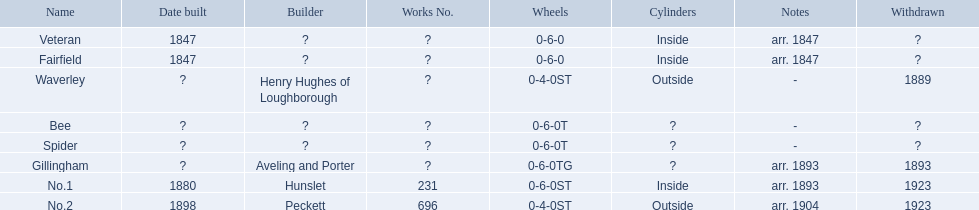What are the names of the alderney railway? Veteran, Fairfield, Waverley, Bee, Spider, Gillingham, No.1, No.2. When was the farfield constructed? 1847. What other structures were erected that year? Veteran. 